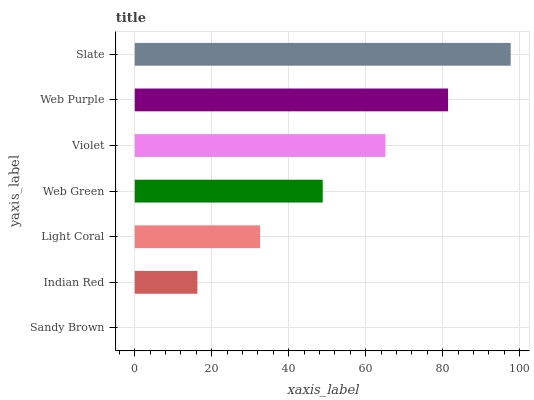Is Sandy Brown the minimum?
Answer yes or no. Yes. Is Slate the maximum?
Answer yes or no. Yes. Is Indian Red the minimum?
Answer yes or no. No. Is Indian Red the maximum?
Answer yes or no. No. Is Indian Red greater than Sandy Brown?
Answer yes or no. Yes. Is Sandy Brown less than Indian Red?
Answer yes or no. Yes. Is Sandy Brown greater than Indian Red?
Answer yes or no. No. Is Indian Red less than Sandy Brown?
Answer yes or no. No. Is Web Green the high median?
Answer yes or no. Yes. Is Web Green the low median?
Answer yes or no. Yes. Is Web Purple the high median?
Answer yes or no. No. Is Sandy Brown the low median?
Answer yes or no. No. 